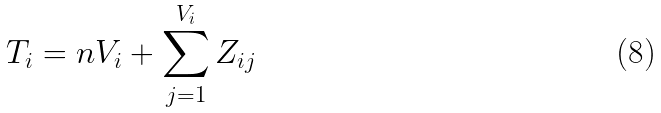<formula> <loc_0><loc_0><loc_500><loc_500>T _ { i } = n V _ { i } + \sum _ { j = 1 } ^ { V _ { i } } Z _ { i j }</formula> 